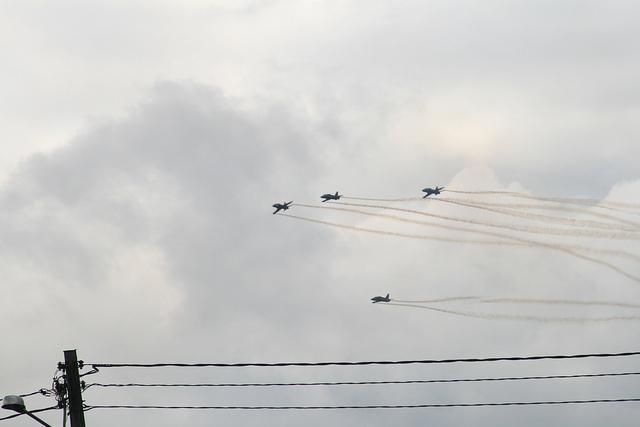How many wires are there?
Give a very brief answer. 3. How many wires are attached to the pole?
Give a very brief answer. 3. How many people is the elephant interacting with?
Give a very brief answer. 0. 